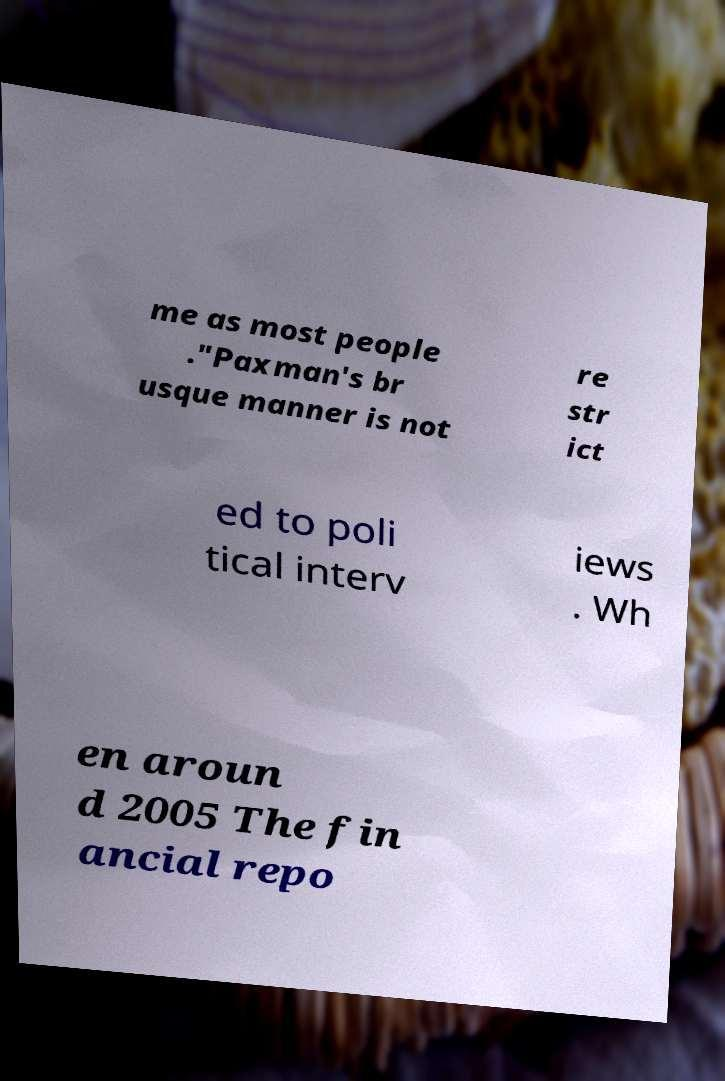I need the written content from this picture converted into text. Can you do that? me as most people ."Paxman's br usque manner is not re str ict ed to poli tical interv iews . Wh en aroun d 2005 The fin ancial repo 